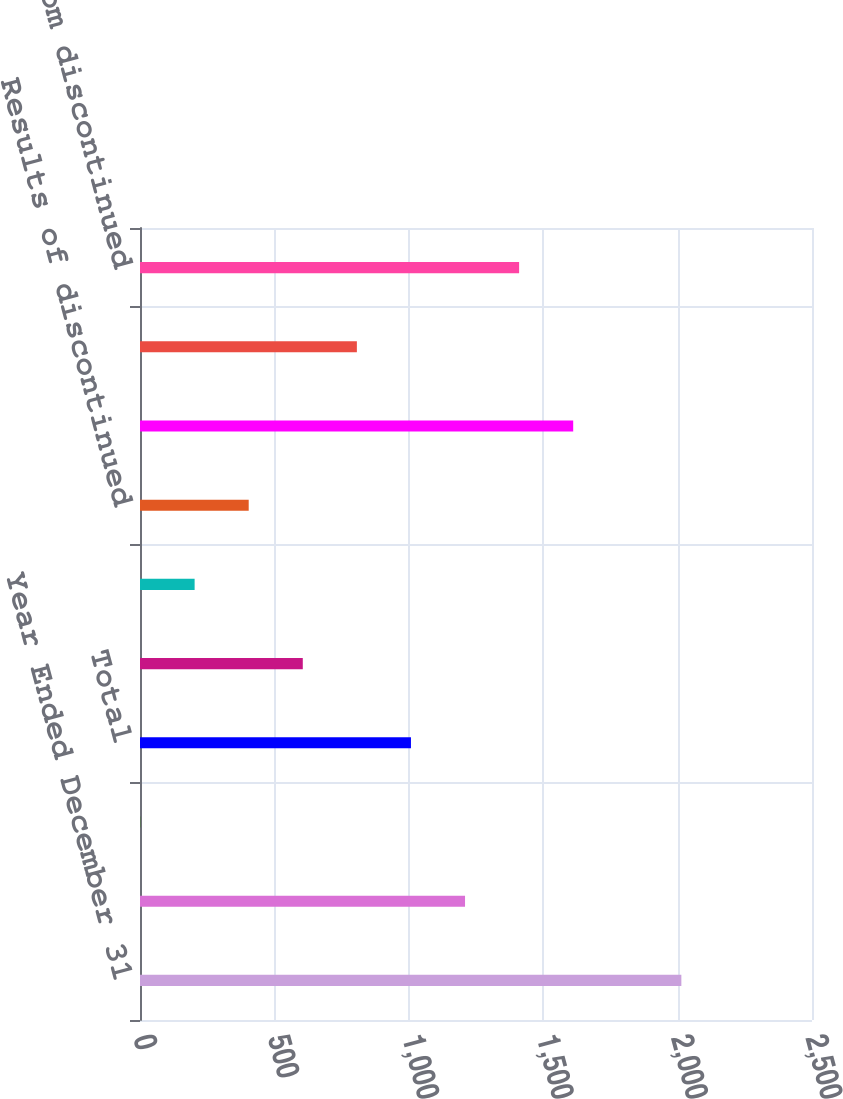<chart> <loc_0><loc_0><loc_500><loc_500><bar_chart><fcel>Year Ended December 31<fcel>Expenses<fcel>Insurance claims and<fcel>Total<fcel>Income before income tax<fcel>Income tax expense<fcel>Results of discontinued<fcel>Loss on sale net of tax<fcel>Amounts attributable to<fcel>Loss from discontinued<nl><fcel>2014<fcel>1209.2<fcel>2<fcel>1008<fcel>605.6<fcel>203.2<fcel>404.4<fcel>1611.6<fcel>806.8<fcel>1410.4<nl></chart> 